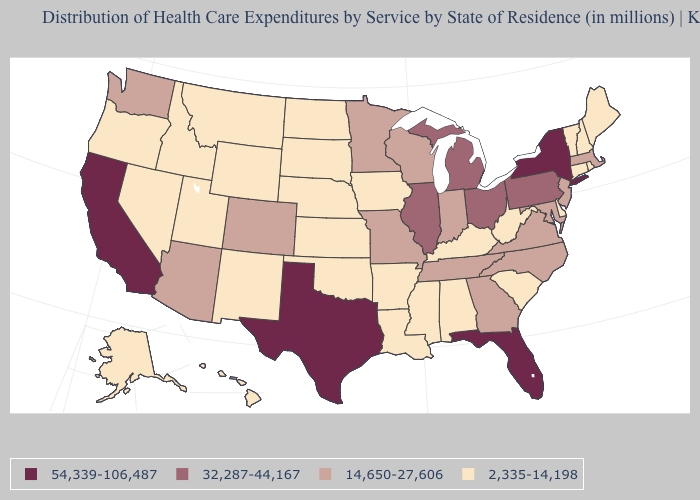How many symbols are there in the legend?
Concise answer only. 4. Does the map have missing data?
Keep it brief. No. What is the value of Georgia?
Give a very brief answer. 14,650-27,606. What is the value of California?
Write a very short answer. 54,339-106,487. What is the value of Alaska?
Short answer required. 2,335-14,198. Does Illinois have a higher value than Pennsylvania?
Concise answer only. No. Does Delaware have the highest value in the USA?
Keep it brief. No. What is the value of Virginia?
Write a very short answer. 14,650-27,606. Which states have the highest value in the USA?
Concise answer only. California, Florida, New York, Texas. What is the lowest value in states that border South Carolina?
Answer briefly. 14,650-27,606. Does Texas have the lowest value in the USA?
Concise answer only. No. Which states have the highest value in the USA?
Answer briefly. California, Florida, New York, Texas. What is the value of Arkansas?
Concise answer only. 2,335-14,198. Which states hav the highest value in the Northeast?
Quick response, please. New York. Name the states that have a value in the range 32,287-44,167?
Keep it brief. Illinois, Michigan, Ohio, Pennsylvania. 